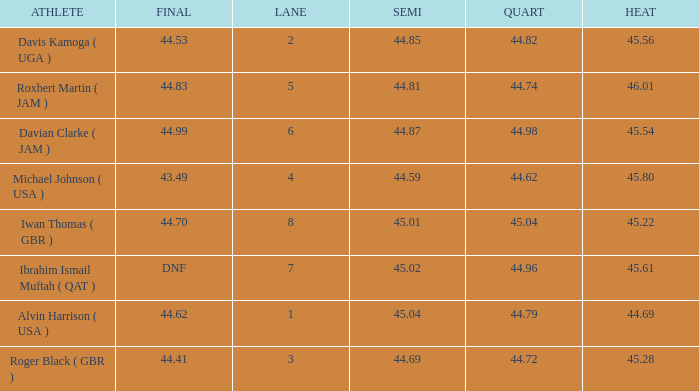When a lane of 4 has a QUART greater than 44.62, what is the lowest HEAT? None. 